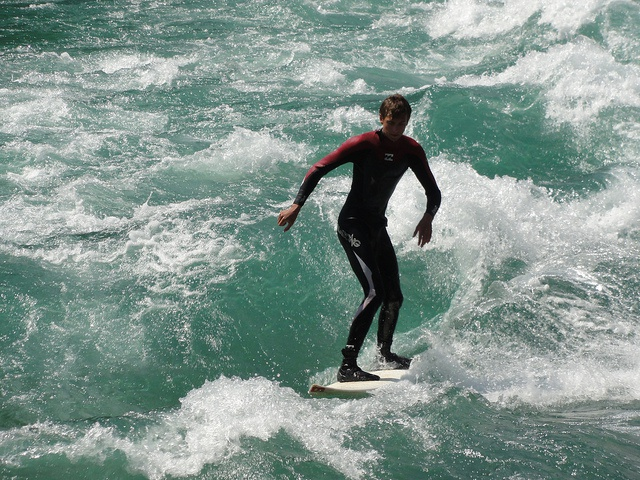Describe the objects in this image and their specific colors. I can see people in purple, black, teal, darkgray, and lightgray tones and surfboard in purple, beige, gray, darkgray, and darkgreen tones in this image. 